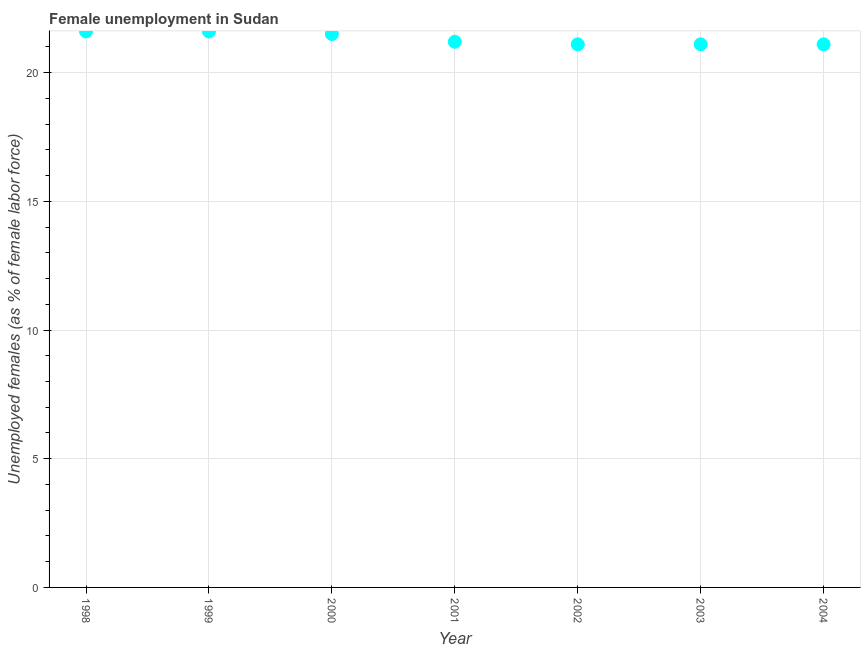Across all years, what is the maximum unemployed females population?
Provide a short and direct response. 21.6. Across all years, what is the minimum unemployed females population?
Make the answer very short. 21.1. In which year was the unemployed females population minimum?
Provide a succinct answer. 2002. What is the sum of the unemployed females population?
Make the answer very short. 149.2. What is the difference between the unemployed females population in 1999 and 2002?
Offer a very short reply. 0.5. What is the average unemployed females population per year?
Your answer should be compact. 21.31. What is the median unemployed females population?
Your answer should be very brief. 21.2. In how many years, is the unemployed females population greater than 6 %?
Your answer should be very brief. 7. Do a majority of the years between 1998 and 1999 (inclusive) have unemployed females population greater than 3 %?
Provide a short and direct response. Yes. What is the ratio of the unemployed females population in 2000 to that in 2004?
Provide a succinct answer. 1.02. Is the unemployed females population in 2000 less than that in 2004?
Your answer should be very brief. No. Is the difference between the unemployed females population in 2002 and 2004 greater than the difference between any two years?
Provide a short and direct response. No. What is the difference between the highest and the second highest unemployed females population?
Provide a succinct answer. 0. What is the difference between the highest and the lowest unemployed females population?
Make the answer very short. 0.5. In how many years, is the unemployed females population greater than the average unemployed females population taken over all years?
Offer a terse response. 3. How many dotlines are there?
Keep it short and to the point. 1. How many years are there in the graph?
Ensure brevity in your answer.  7. Does the graph contain any zero values?
Keep it short and to the point. No. Does the graph contain grids?
Your answer should be compact. Yes. What is the title of the graph?
Provide a succinct answer. Female unemployment in Sudan. What is the label or title of the X-axis?
Offer a very short reply. Year. What is the label or title of the Y-axis?
Offer a terse response. Unemployed females (as % of female labor force). What is the Unemployed females (as % of female labor force) in 1998?
Keep it short and to the point. 21.6. What is the Unemployed females (as % of female labor force) in 1999?
Keep it short and to the point. 21.6. What is the Unemployed females (as % of female labor force) in 2000?
Provide a short and direct response. 21.5. What is the Unemployed females (as % of female labor force) in 2001?
Keep it short and to the point. 21.2. What is the Unemployed females (as % of female labor force) in 2002?
Offer a terse response. 21.1. What is the Unemployed females (as % of female labor force) in 2003?
Keep it short and to the point. 21.1. What is the Unemployed females (as % of female labor force) in 2004?
Provide a succinct answer. 21.1. What is the difference between the Unemployed females (as % of female labor force) in 1998 and 1999?
Offer a terse response. 0. What is the difference between the Unemployed females (as % of female labor force) in 1998 and 2001?
Your answer should be compact. 0.4. What is the difference between the Unemployed females (as % of female labor force) in 1998 and 2002?
Your response must be concise. 0.5. What is the difference between the Unemployed females (as % of female labor force) in 1998 and 2004?
Your answer should be compact. 0.5. What is the difference between the Unemployed females (as % of female labor force) in 1999 and 2000?
Provide a succinct answer. 0.1. What is the difference between the Unemployed females (as % of female labor force) in 1999 and 2001?
Your response must be concise. 0.4. What is the difference between the Unemployed females (as % of female labor force) in 1999 and 2003?
Your response must be concise. 0.5. What is the difference between the Unemployed females (as % of female labor force) in 1999 and 2004?
Your response must be concise. 0.5. What is the difference between the Unemployed females (as % of female labor force) in 2000 and 2001?
Make the answer very short. 0.3. What is the difference between the Unemployed females (as % of female labor force) in 2000 and 2004?
Provide a short and direct response. 0.4. What is the difference between the Unemployed females (as % of female labor force) in 2001 and 2003?
Provide a short and direct response. 0.1. What is the difference between the Unemployed females (as % of female labor force) in 2001 and 2004?
Provide a short and direct response. 0.1. What is the difference between the Unemployed females (as % of female labor force) in 2002 and 2004?
Give a very brief answer. 0. What is the ratio of the Unemployed females (as % of female labor force) in 1998 to that in 1999?
Make the answer very short. 1. What is the ratio of the Unemployed females (as % of female labor force) in 1998 to that in 2002?
Provide a short and direct response. 1.02. What is the ratio of the Unemployed females (as % of female labor force) in 1998 to that in 2003?
Your response must be concise. 1.02. What is the ratio of the Unemployed females (as % of female labor force) in 1998 to that in 2004?
Your answer should be compact. 1.02. What is the ratio of the Unemployed females (as % of female labor force) in 1999 to that in 2002?
Ensure brevity in your answer.  1.02. What is the ratio of the Unemployed females (as % of female labor force) in 2000 to that in 2001?
Your answer should be compact. 1.01. What is the ratio of the Unemployed females (as % of female labor force) in 2000 to that in 2003?
Your answer should be very brief. 1.02. What is the ratio of the Unemployed females (as % of female labor force) in 2000 to that in 2004?
Give a very brief answer. 1.02. What is the ratio of the Unemployed females (as % of female labor force) in 2001 to that in 2002?
Ensure brevity in your answer.  1. What is the ratio of the Unemployed females (as % of female labor force) in 2001 to that in 2003?
Ensure brevity in your answer.  1. What is the ratio of the Unemployed females (as % of female labor force) in 2001 to that in 2004?
Provide a succinct answer. 1. What is the ratio of the Unemployed females (as % of female labor force) in 2002 to that in 2004?
Keep it short and to the point. 1. 